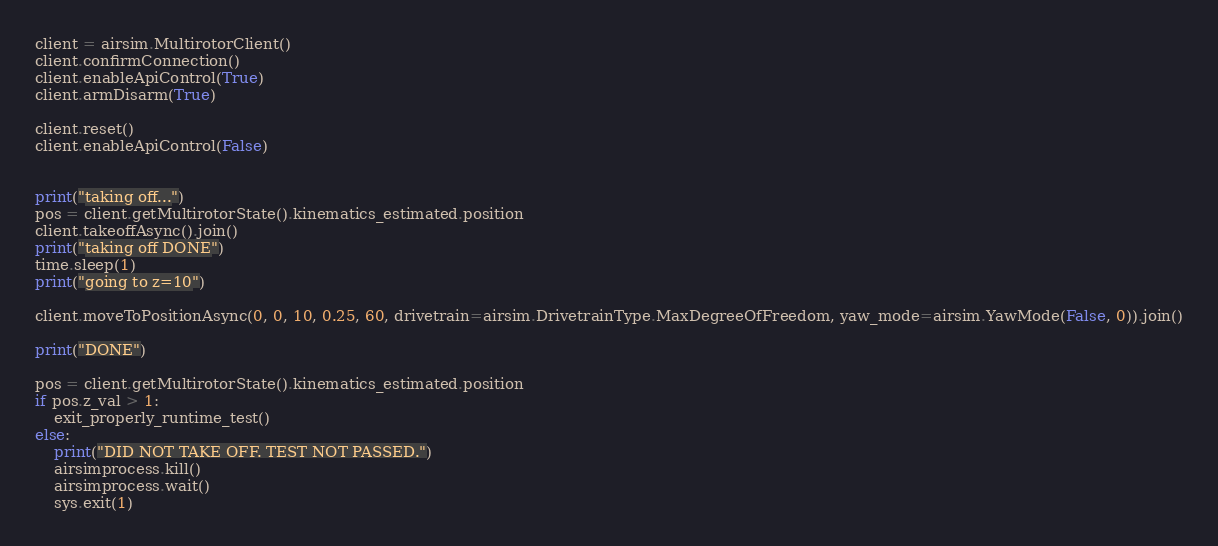<code> <loc_0><loc_0><loc_500><loc_500><_Python_>client = airsim.MultirotorClient()
client.confirmConnection()
client.enableApiControl(True)
client.armDisarm(True)

client.reset()
client.enableApiControl(False)


print("taking off...")
pos = client.getMultirotorState().kinematics_estimated.position
client.takeoffAsync().join()
print("taking off DONE")
time.sleep(1)
print("going to z=10")

client.moveToPositionAsync(0, 0, 10, 0.25, 60, drivetrain=airsim.DrivetrainType.MaxDegreeOfFreedom, yaw_mode=airsim.YawMode(False, 0)).join()

print("DONE")

pos = client.getMultirotorState().kinematics_estimated.position
if pos.z_val > 1:
    exit_properly_runtime_test()
else:
    print("DID NOT TAKE OFF. TEST NOT PASSED.")
    airsimprocess.kill()
    airsimprocess.wait()
    sys.exit(1)</code> 